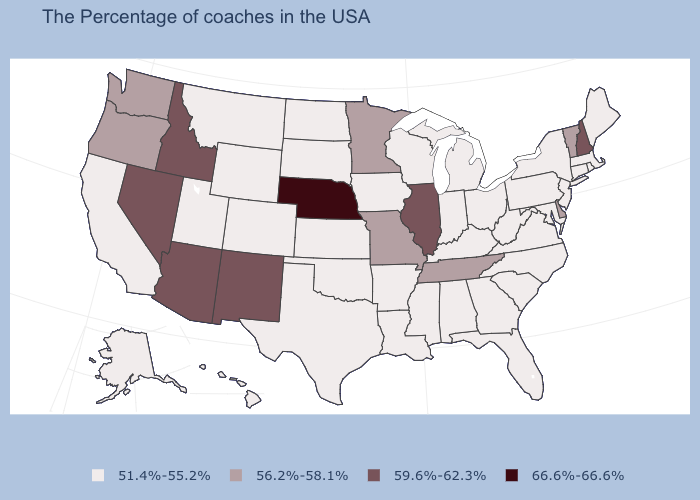Which states have the lowest value in the Northeast?
Keep it brief. Maine, Massachusetts, Rhode Island, Connecticut, New York, New Jersey, Pennsylvania. What is the value of Wisconsin?
Short answer required. 51.4%-55.2%. Does Vermont have a higher value than Kansas?
Concise answer only. Yes. Which states hav the highest value in the West?
Short answer required. New Mexico, Arizona, Idaho, Nevada. What is the value of Illinois?
Write a very short answer. 59.6%-62.3%. Name the states that have a value in the range 51.4%-55.2%?
Write a very short answer. Maine, Massachusetts, Rhode Island, Connecticut, New York, New Jersey, Maryland, Pennsylvania, Virginia, North Carolina, South Carolina, West Virginia, Ohio, Florida, Georgia, Michigan, Kentucky, Indiana, Alabama, Wisconsin, Mississippi, Louisiana, Arkansas, Iowa, Kansas, Oklahoma, Texas, South Dakota, North Dakota, Wyoming, Colorado, Utah, Montana, California, Alaska, Hawaii. Which states have the lowest value in the USA?
Answer briefly. Maine, Massachusetts, Rhode Island, Connecticut, New York, New Jersey, Maryland, Pennsylvania, Virginia, North Carolina, South Carolina, West Virginia, Ohio, Florida, Georgia, Michigan, Kentucky, Indiana, Alabama, Wisconsin, Mississippi, Louisiana, Arkansas, Iowa, Kansas, Oklahoma, Texas, South Dakota, North Dakota, Wyoming, Colorado, Utah, Montana, California, Alaska, Hawaii. Among the states that border Vermont , does Massachusetts have the lowest value?
Write a very short answer. Yes. How many symbols are there in the legend?
Write a very short answer. 4. Does Mississippi have the lowest value in the South?
Short answer required. Yes. What is the value of South Carolina?
Be succinct. 51.4%-55.2%. What is the value of Colorado?
Quick response, please. 51.4%-55.2%. Is the legend a continuous bar?
Short answer required. No. Name the states that have a value in the range 51.4%-55.2%?
Give a very brief answer. Maine, Massachusetts, Rhode Island, Connecticut, New York, New Jersey, Maryland, Pennsylvania, Virginia, North Carolina, South Carolina, West Virginia, Ohio, Florida, Georgia, Michigan, Kentucky, Indiana, Alabama, Wisconsin, Mississippi, Louisiana, Arkansas, Iowa, Kansas, Oklahoma, Texas, South Dakota, North Dakota, Wyoming, Colorado, Utah, Montana, California, Alaska, Hawaii. Does Tennessee have the lowest value in the South?
Answer briefly. No. 